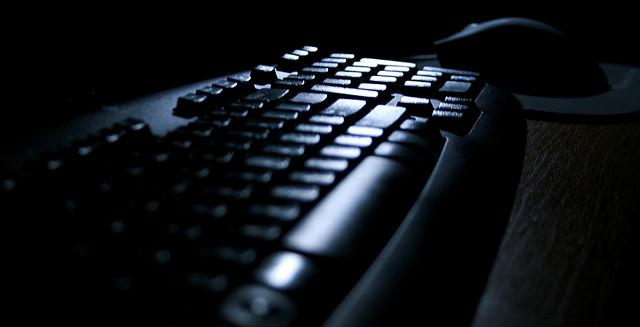Does this keyboard have a number pad?
Concise answer only. Yes. Will anyone be using this keyboard?
Answer briefly. Yes. What computer components are shown in this picture?
Short answer required. Keyboard. Is the room dark?
Write a very short answer. Yes. What color is the computer keyboard?
Be succinct. Black. What color is the keyboard?
Answer briefly. Black. What brand of computer is this?
Keep it brief. Dell. What color are the keys?
Answer briefly. Black. What do you think is the most common type of item in the cases?
Short answer required. Keyboard. 